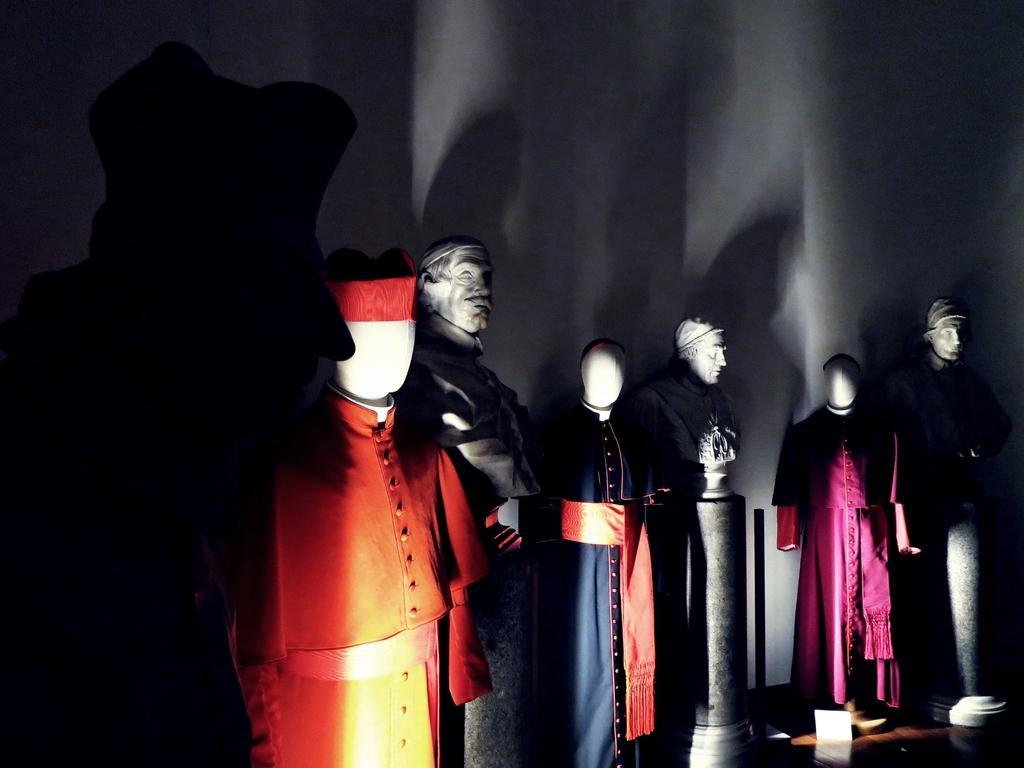Could you give a brief overview of what you see in this image? In this image we can see the mannequins with the clothes. We can also see the wall and also the floor. 